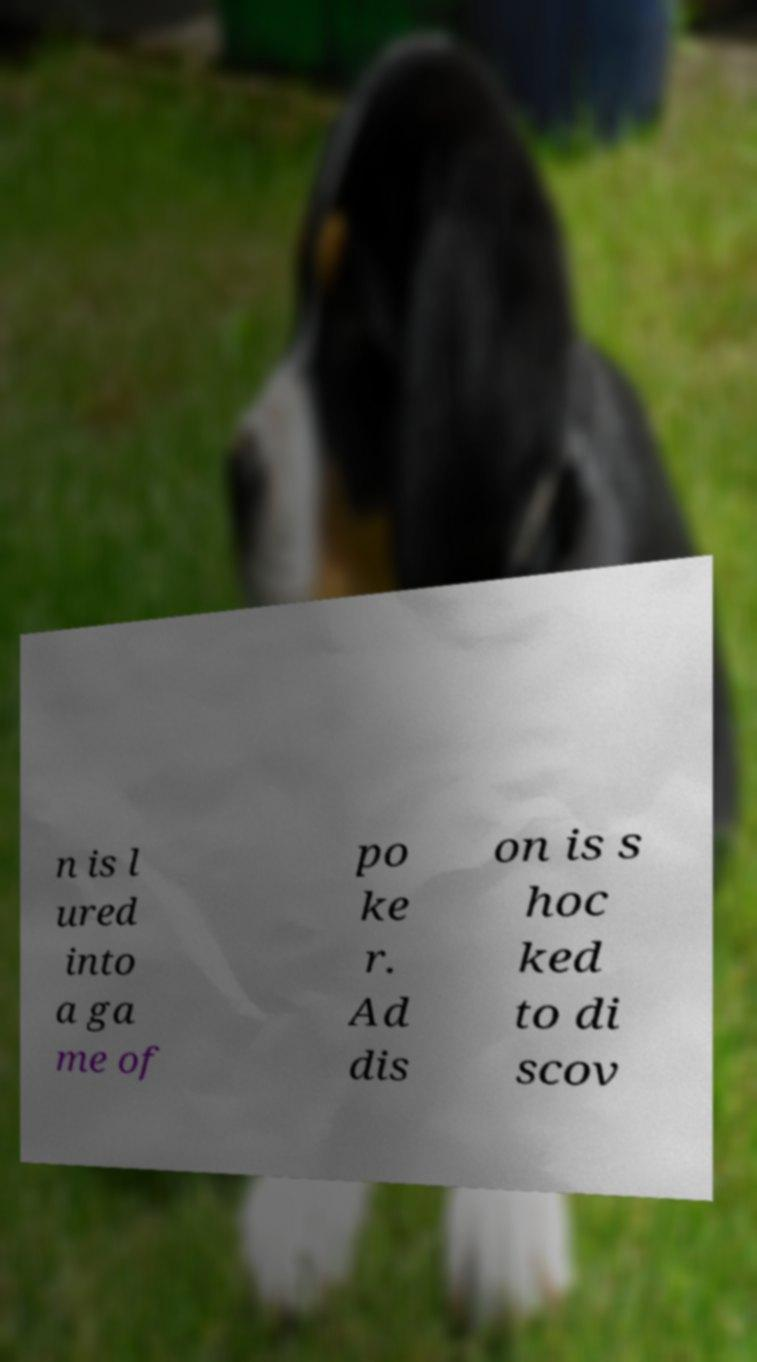Could you extract and type out the text from this image? n is l ured into a ga me of po ke r. Ad dis on is s hoc ked to di scov 